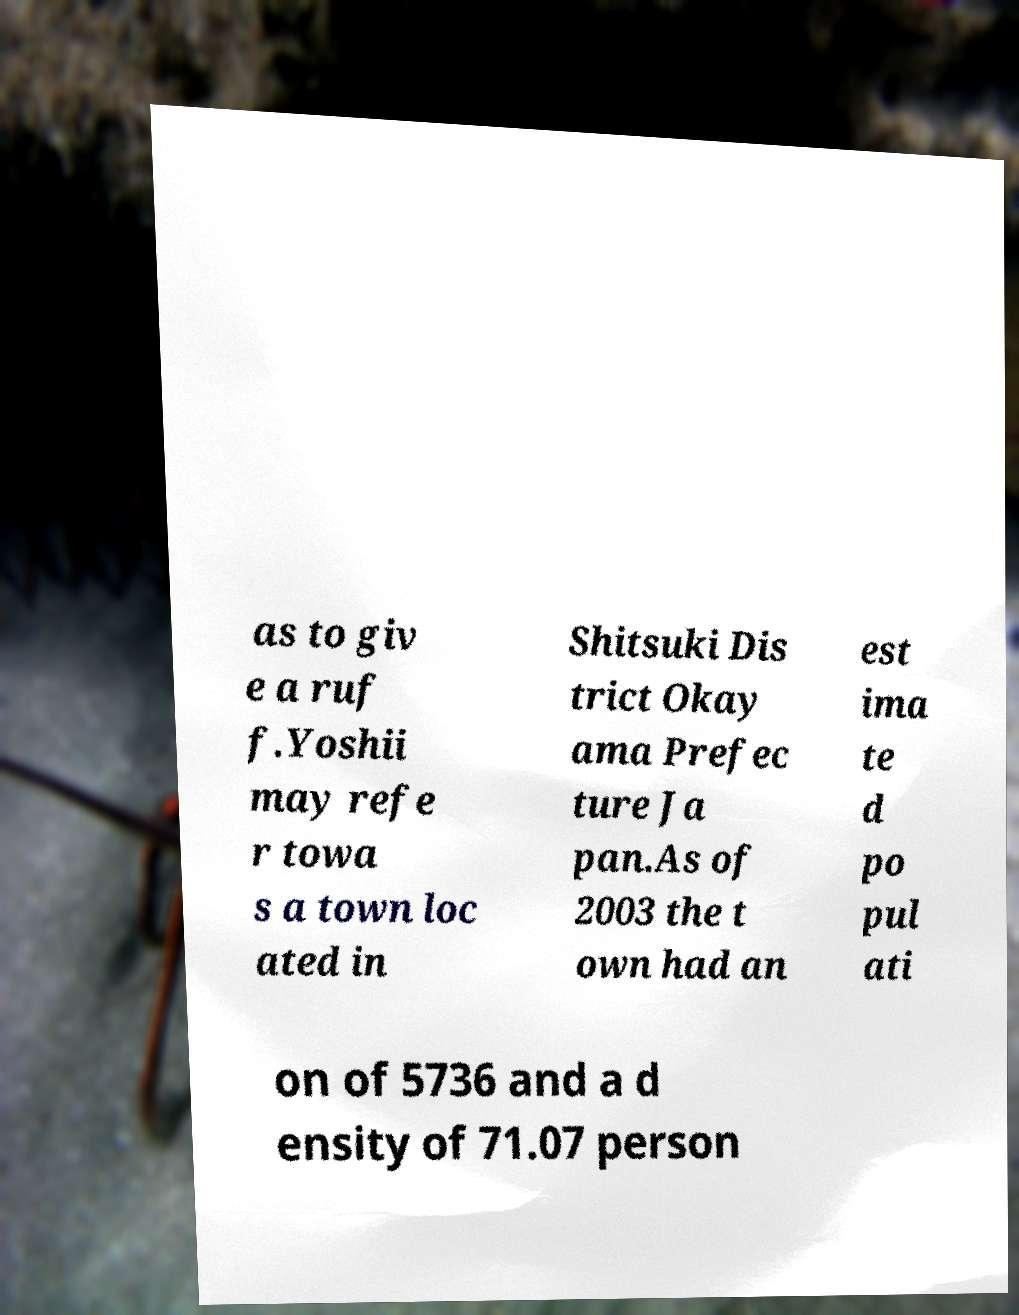Can you read and provide the text displayed in the image?This photo seems to have some interesting text. Can you extract and type it out for me? as to giv e a ruf f.Yoshii may refe r towa s a town loc ated in Shitsuki Dis trict Okay ama Prefec ture Ja pan.As of 2003 the t own had an est ima te d po pul ati on of 5736 and a d ensity of 71.07 person 